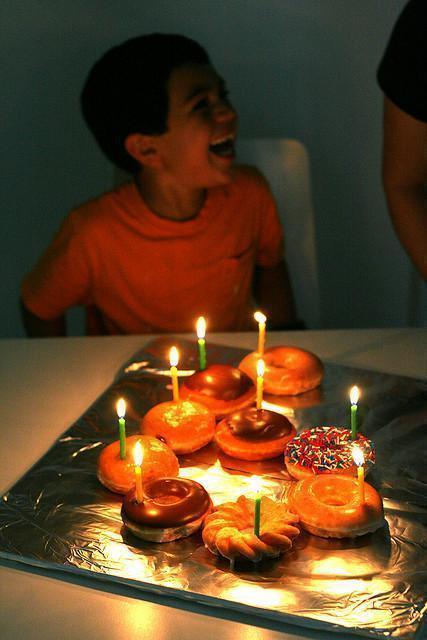What color is the only icing element used for the birthday donuts?
Select the accurate response from the four choices given to answer the question.
Options: Brown, white, pink, light brown. Brown. 